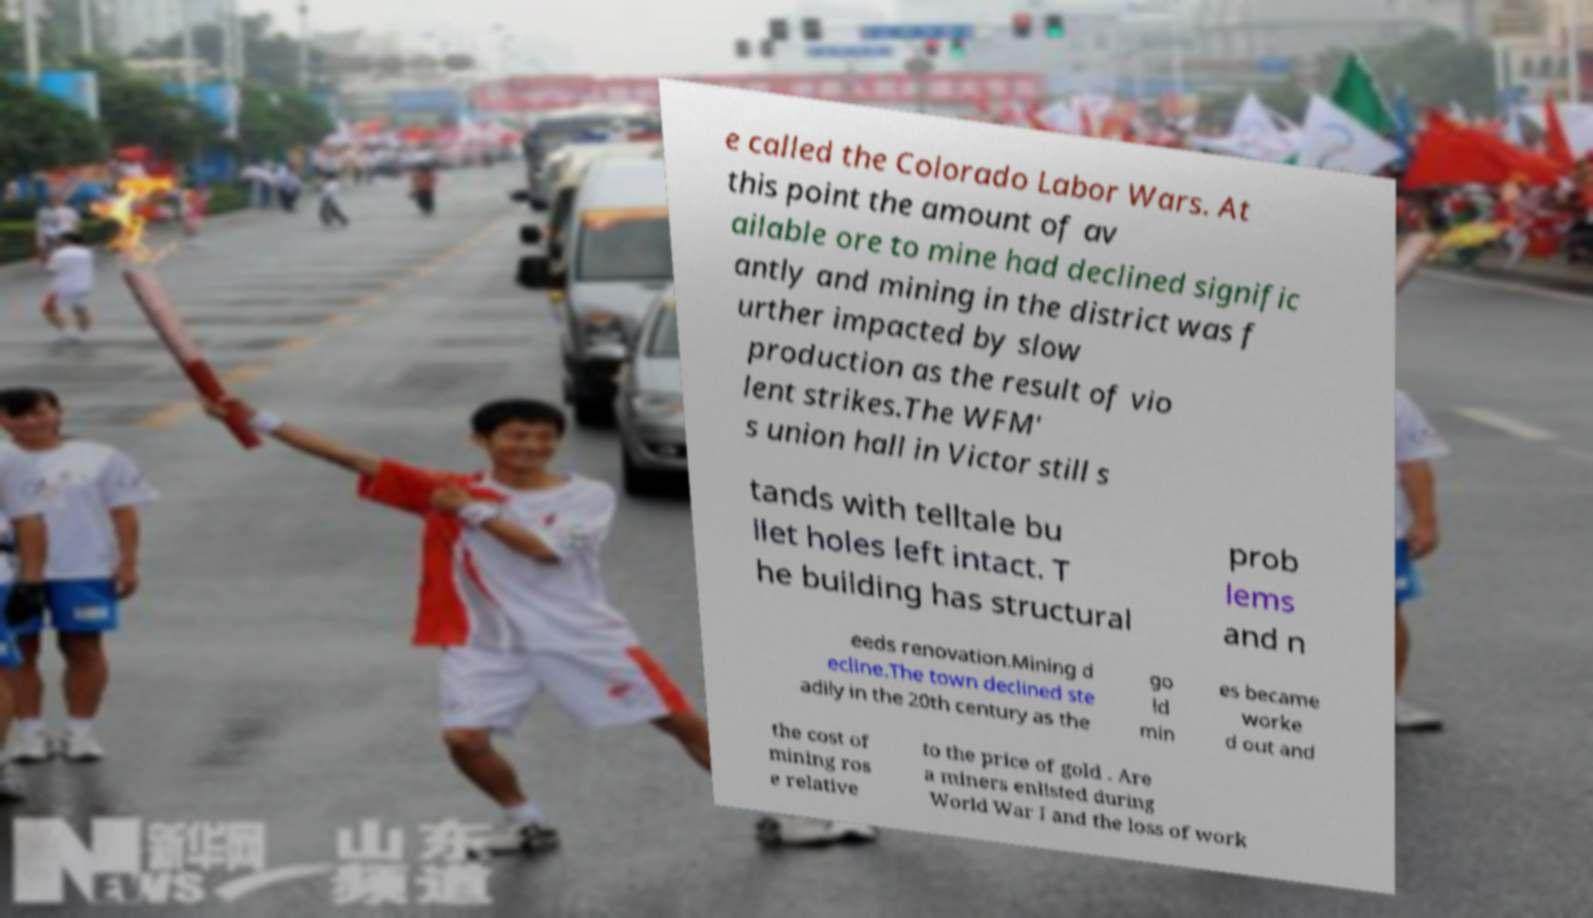Please read and relay the text visible in this image. What does it say? e called the Colorado Labor Wars. At this point the amount of av ailable ore to mine had declined signific antly and mining in the district was f urther impacted by slow production as the result of vio lent strikes.The WFM' s union hall in Victor still s tands with telltale bu llet holes left intact. T he building has structural prob lems and n eeds renovation.Mining d ecline.The town declined ste adily in the 20th century as the go ld min es became worke d out and the cost of mining ros e relative to the price of gold . Are a miners enlisted during World War I and the loss of work 